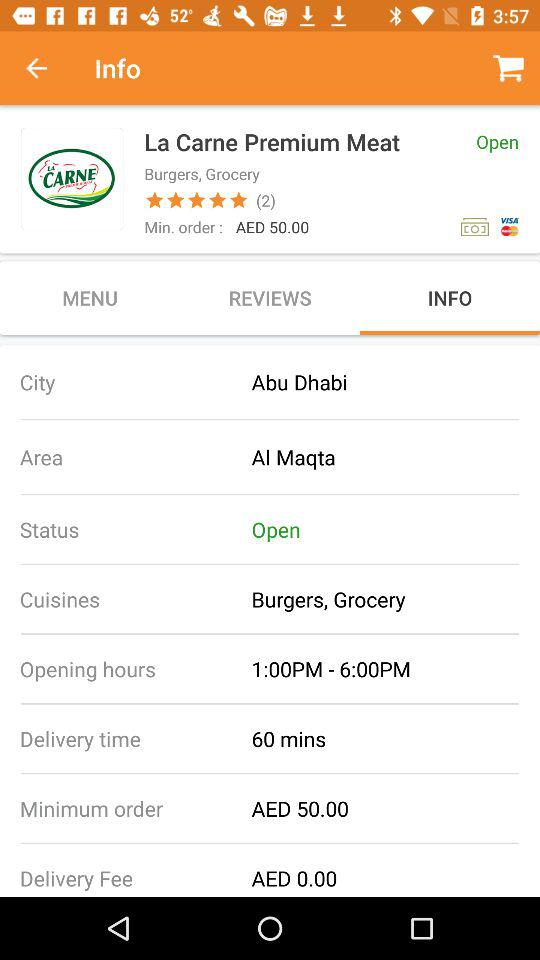What is the cost of delivery? The cost of delivery is AED 0.00. 